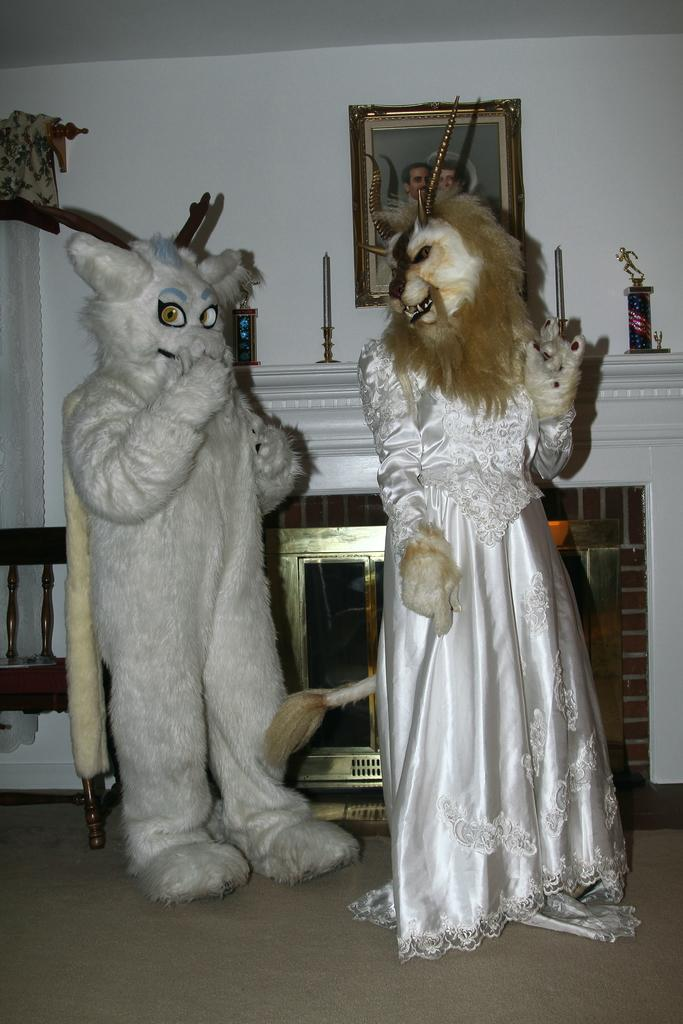What is the main subject of the image? The main subject of the image is the persons in the center of the image. What are the persons wearing? The persons are wearing costumes of animals. What can be seen on the wall in the background of the image? There is a frame on the wall in the background of the image. What is the purpose of the empty chair in front of the wall in the background of the image? The empty chair in front of the wall in the background of the image might be for someone to sit and observe the scene or for someone to join the persons wearing animal costumes. What type of veil is draped over the animal costumes in the image? There is no veil present in the image; the persons are wearing animal costumes without any additional coverings. 